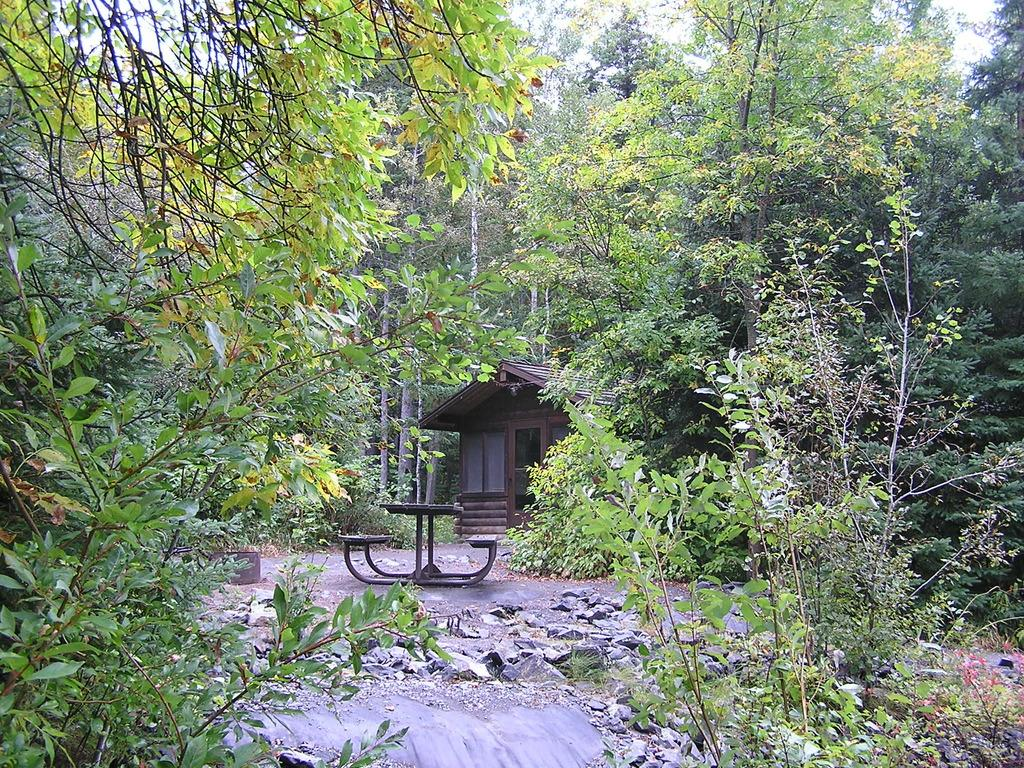What type of living organisms can be seen in the image? Plants are visible in the image. What type of furniture can be seen in the background of the image? There is a table and benches in the background of the image. What type of structure is visible in the background of the image? There is a house in the background of the image. What type of natural environment is visible in the background of the image? There are many trees and the sky visible in the background of the image. What type of vegetable is being argued about in the image? There is no argument or vegetable present in the image. 